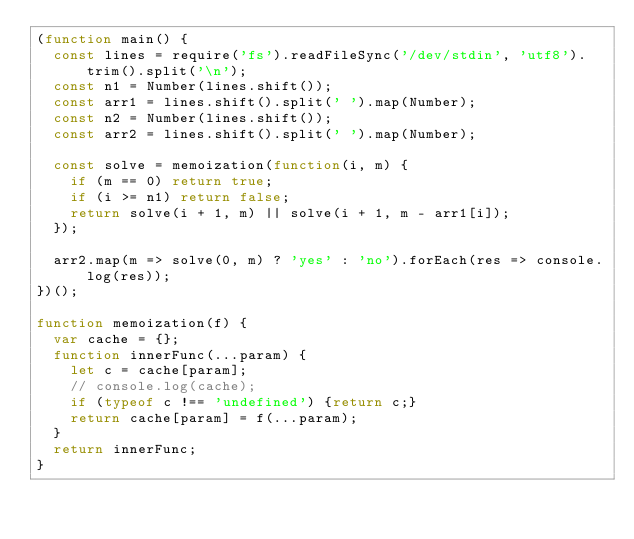<code> <loc_0><loc_0><loc_500><loc_500><_JavaScript_>(function main() {
  const lines = require('fs').readFileSync('/dev/stdin', 'utf8').trim().split('\n');
  const n1 = Number(lines.shift());
  const arr1 = lines.shift().split(' ').map(Number);
  const n2 = Number(lines.shift());
  const arr2 = lines.shift().split(' ').map(Number);

  const solve = memoization(function(i, m) {
    if (m == 0) return true;
    if (i >= n1) return false;
    return solve(i + 1, m) || solve(i + 1, m - arr1[i]);
  });

  arr2.map(m => solve(0, m) ? 'yes' : 'no').forEach(res => console.log(res));
})();

function memoization(f) {
  var cache = {};
  function innerFunc(...param) {
    let c = cache[param];
    // console.log(cache);
    if (typeof c !== 'undefined') {return c;}
    return cache[param] = f(...param);
  }
  return innerFunc;
}

</code> 